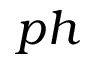<formula> <loc_0><loc_0><loc_500><loc_500>p h</formula> 